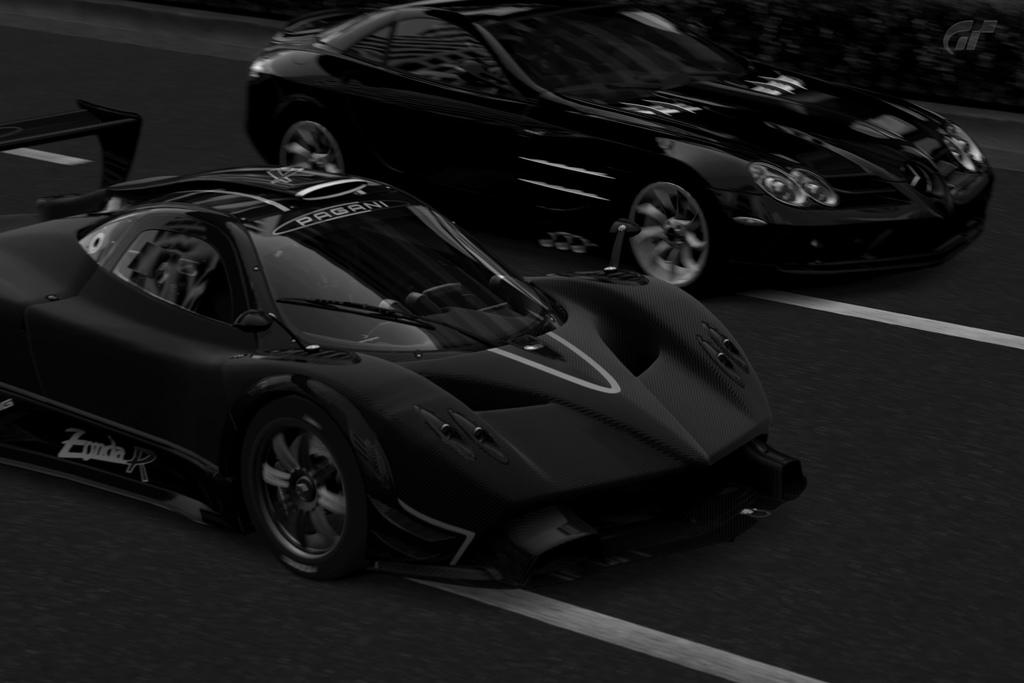How many cars are visible in the image? There are two cars in the image. Where are the cars located? The cars are on the road. What is the color scheme of the image? The image is black and white. What type of zephyr can be seen blowing through the mine in the image? There is no zephyr or mine present in the image; it features two cars on the road in a black and white setting. 